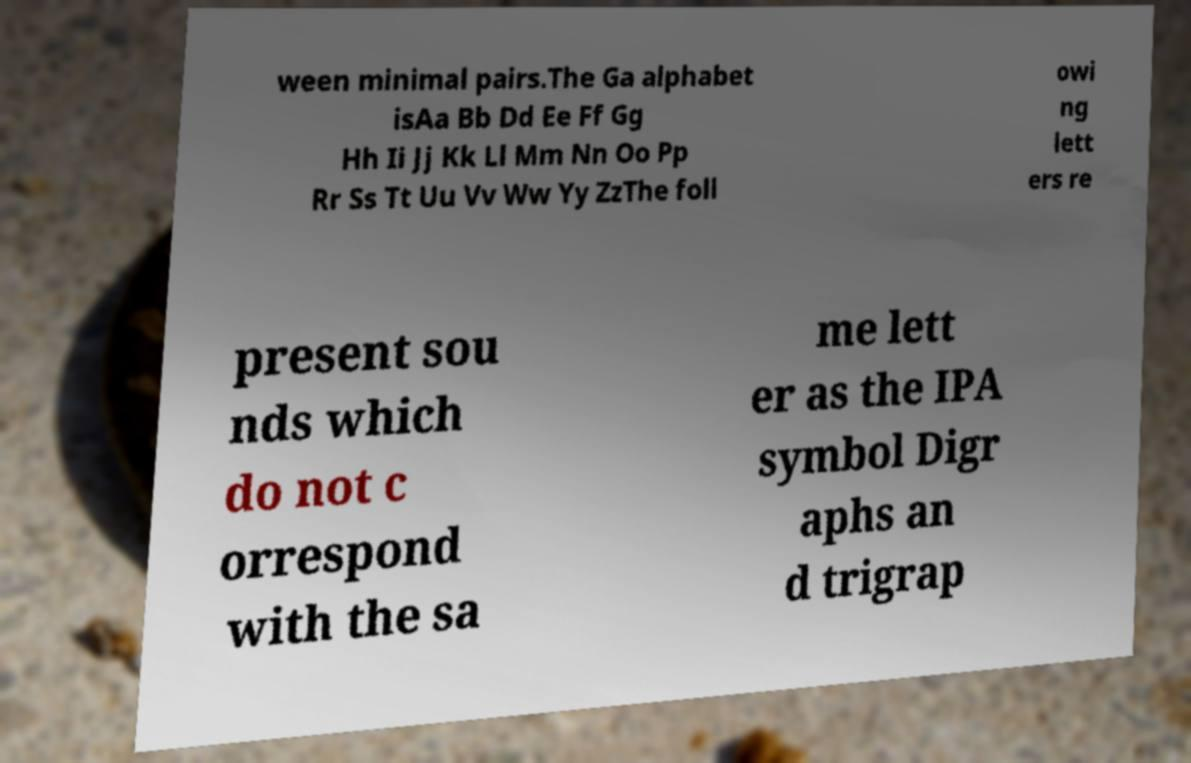Please identify and transcribe the text found in this image. ween minimal pairs.The Ga alphabet isAa Bb Dd Ee Ff Gg Hh Ii Jj Kk Ll Mm Nn Oo Pp Rr Ss Tt Uu Vv Ww Yy ZzThe foll owi ng lett ers re present sou nds which do not c orrespond with the sa me lett er as the IPA symbol Digr aphs an d trigrap 